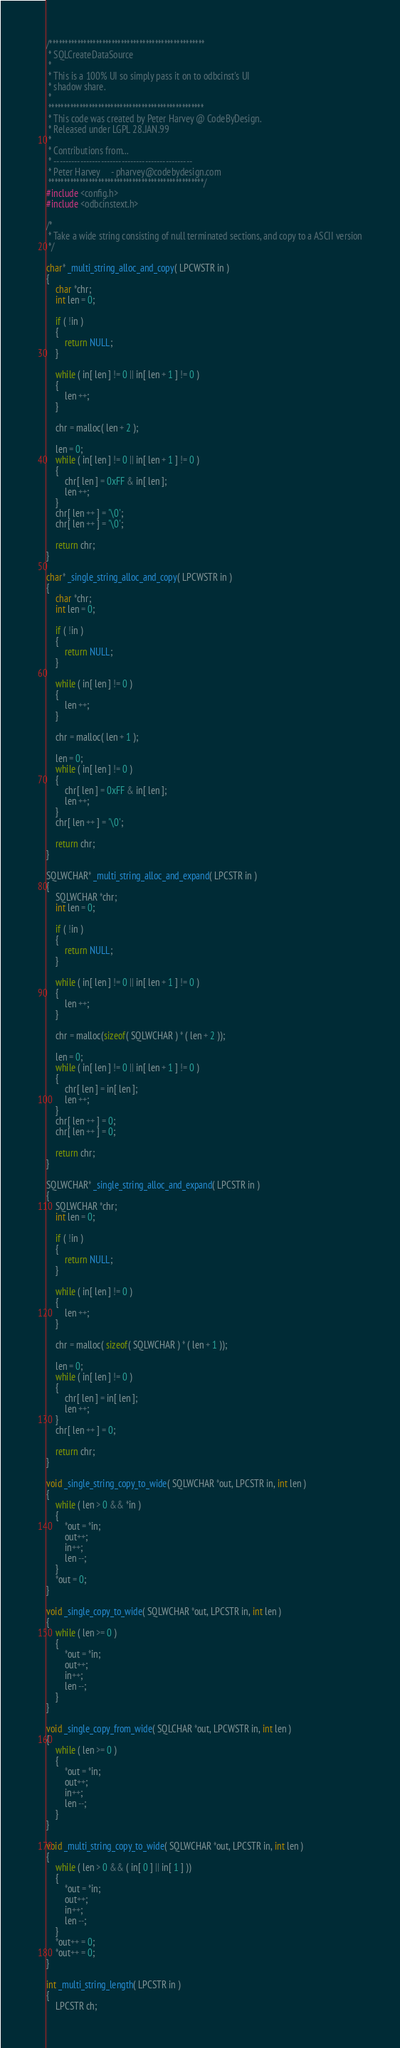<code> <loc_0><loc_0><loc_500><loc_500><_C_>/**************************************************
 * SQLCreateDataSource
 *
 * This is a 100% UI so simply pass it on to odbcinst's UI
 * shadow share.
 *
 **************************************************
 * This code was created by Peter Harvey @ CodeByDesign.
 * Released under LGPL 28.JAN.99
 *
 * Contributions from...
 * -----------------------------------------------
 * Peter Harvey		- pharvey@codebydesign.com
 **************************************************/
#include <config.h>
#include <odbcinstext.h>

/*
 * Take a wide string consisting of null terminated sections, and copy to a ASCII version
 */

char* _multi_string_alloc_and_copy( LPCWSTR in )
{
    char *chr;
    int len = 0;

    if ( !in )
    {
        return NULL;
    }

    while ( in[ len ] != 0 || in[ len + 1 ] != 0 )
    {
        len ++;
    }

    chr = malloc( len + 2 );

    len = 0;
    while ( in[ len ] != 0 || in[ len + 1 ] != 0 )
    {
        chr[ len ] = 0xFF & in[ len ];
        len ++;
    }
    chr[ len ++ ] = '\0';
    chr[ len ++ ] = '\0';

    return chr;
}

char* _single_string_alloc_and_copy( LPCWSTR in )
{
    char *chr;
    int len = 0;

    if ( !in )
    {
        return NULL;
    }

    while ( in[ len ] != 0 )
    {
        len ++;
    }

    chr = malloc( len + 1 );

    len = 0;
    while ( in[ len ] != 0 )
    {
        chr[ len ] = 0xFF & in[ len ];
        len ++;
    }
    chr[ len ++ ] = '\0';

    return chr;
}

SQLWCHAR* _multi_string_alloc_and_expand( LPCSTR in )
{
    SQLWCHAR *chr;
    int len = 0;

    if ( !in )
    {
        return NULL;
    }
    
    while ( in[ len ] != 0 || in[ len + 1 ] != 0 )
    {
        len ++;
    }

    chr = malloc(sizeof( SQLWCHAR ) * ( len + 2 ));

    len = 0;
    while ( in[ len ] != 0 || in[ len + 1 ] != 0 )
    {
        chr[ len ] = in[ len ];
        len ++;
    }
    chr[ len ++ ] = 0;
    chr[ len ++ ] = 0;

    return chr;
}

SQLWCHAR* _single_string_alloc_and_expand( LPCSTR in )
{
    SQLWCHAR *chr;
    int len = 0;

    if ( !in )
    {
        return NULL;
    }

    while ( in[ len ] != 0 )
    {
        len ++;
    }

    chr = malloc( sizeof( SQLWCHAR ) * ( len + 1 ));

    len = 0;
    while ( in[ len ] != 0 )
    {
        chr[ len ] = in[ len ];
        len ++;
    }
    chr[ len ++ ] = 0;

    return chr;
}

void _single_string_copy_to_wide( SQLWCHAR *out, LPCSTR in, int len )
{
    while ( len > 0 && *in )
    {
        *out = *in;
        out++;
        in++;
        len --;
    }
    *out = 0;
}

void _single_copy_to_wide( SQLWCHAR *out, LPCSTR in, int len )
{
    while ( len >= 0 )
    {
        *out = *in;
        out++;
        in++;
        len --;
    }
}

void _single_copy_from_wide( SQLCHAR *out, LPCWSTR in, int len )
{
    while ( len >= 0 )
    {
        *out = *in;
        out++;
        in++;
        len --;
    }
}

void _multi_string_copy_to_wide( SQLWCHAR *out, LPCSTR in, int len )
{
    while ( len > 0 && ( in[ 0 ] || in[ 1 ] ))
    {
        *out = *in;
        out++;
        in++;
        len --;
    }
    *out++ = 0;
    *out++ = 0;
}

int _multi_string_length( LPCSTR in )
{
    LPCSTR ch;
</code> 